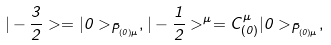Convert formula to latex. <formula><loc_0><loc_0><loc_500><loc_500>| - \frac { 3 } { 2 } > = | 0 > _ { \bar { P } _ { ( 0 ) \mu } } , | - \frac { 1 } { 2 } > ^ { \mu } = C _ { ( 0 ) } ^ { \mu } | 0 > _ { \bar { P } _ { ( 0 ) \mu } } ,</formula> 